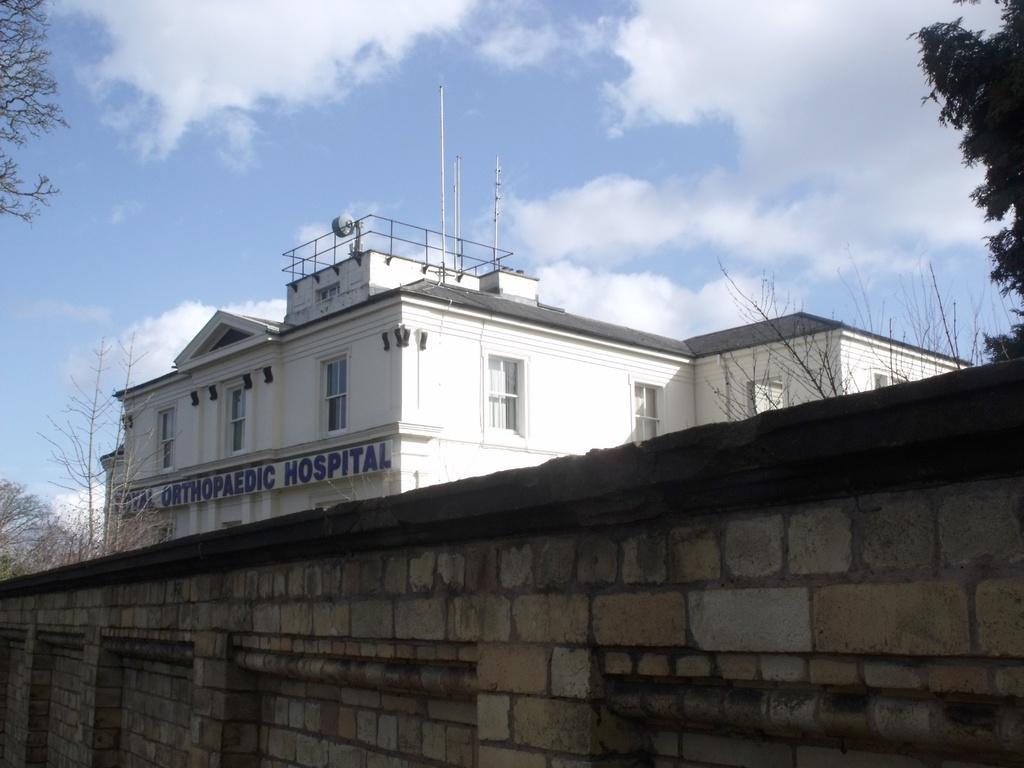In one or two sentences, can you explain what this image depicts? In this image we can see a building and on the building we have some text. In front of the building we can see a wall. On both sides of the image there are few trees and at the top we can see the sky. 